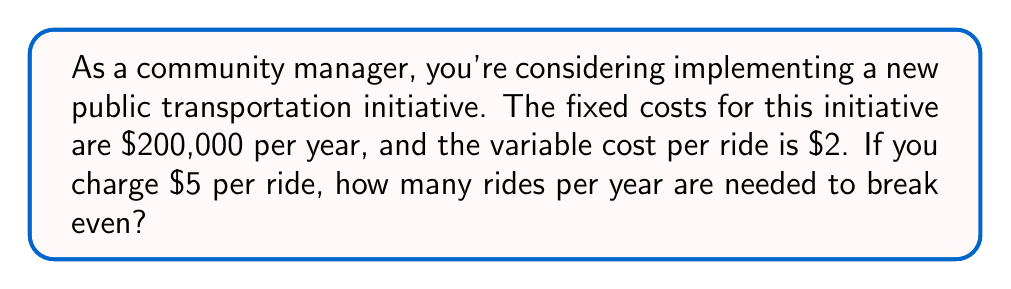Can you answer this question? Let's approach this step-by-step using a linear equation:

1) Define variables:
   Let $x$ = number of rides per year
   Let $y$ = total revenue

2) Express total revenue in terms of rides:
   $y = 5x$ (since each ride costs $5)

3) Express total costs in terms of rides:
   Total Cost = Fixed Costs + Variable Costs
   $TC = 200,000 + 2x$

4) At break-even point, total revenue equals total costs:
   $5x = 200,000 + 2x$

5) Solve the equation:
   $5x - 2x = 200,000$
   $3x = 200,000$
   $x = \frac{200,000}{3} = 66,666.67$

6) Since we can't have a fractional ride, we round up to the nearest whole number.

Therefore, 66,667 rides per year are needed to break even.
Answer: 66,667 rides 